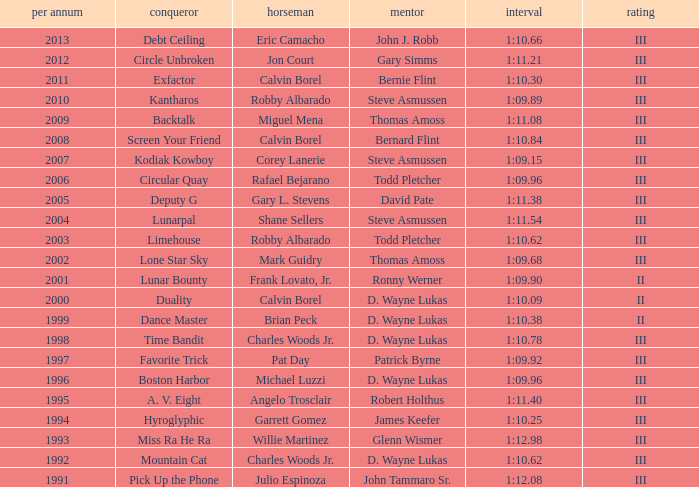Which trainer won the hyroglyphic in a year that was before 2010? James Keefer. 